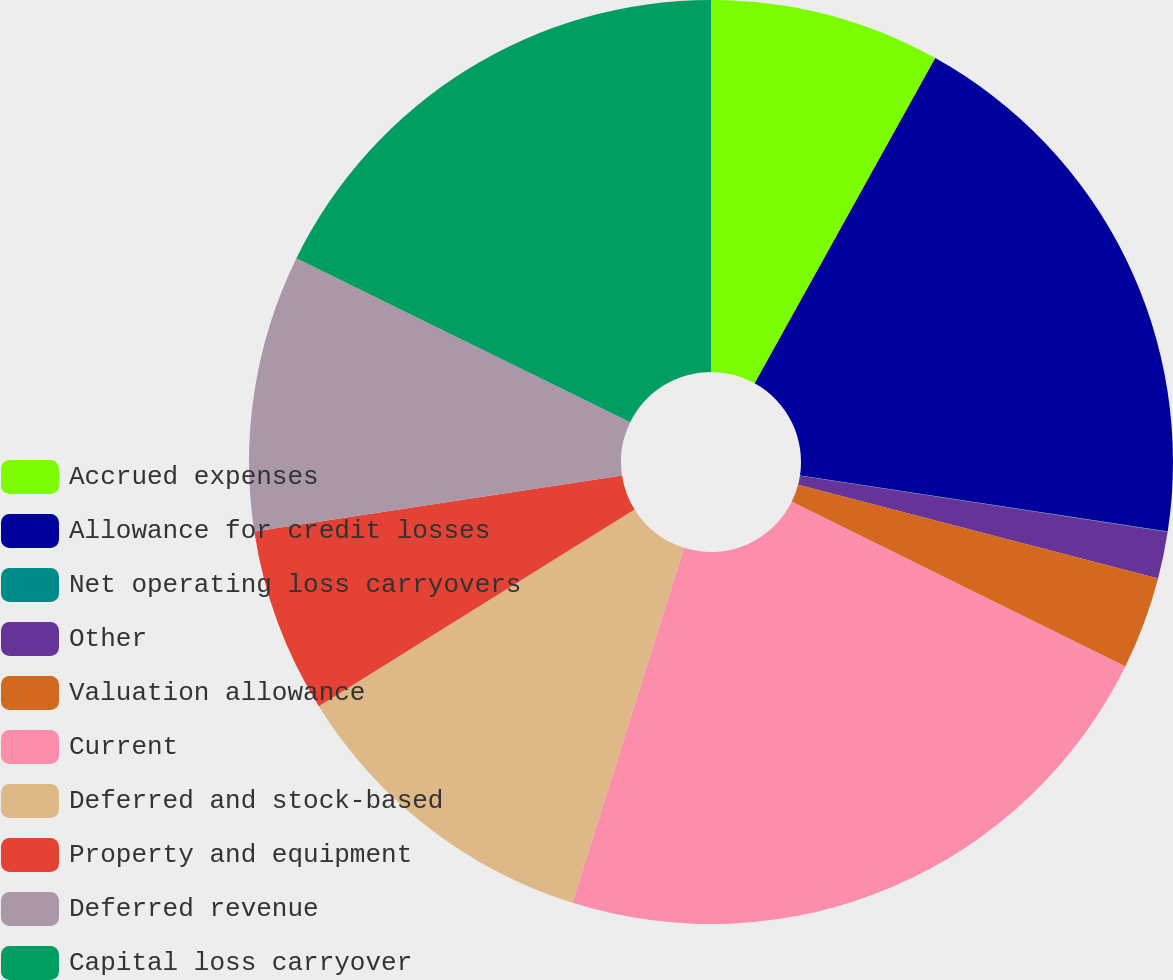Convert chart. <chart><loc_0><loc_0><loc_500><loc_500><pie_chart><fcel>Accrued expenses<fcel>Allowance for credit losses<fcel>Net operating loss carryovers<fcel>Other<fcel>Valuation allowance<fcel>Current<fcel>Deferred and stock-based<fcel>Property and equipment<fcel>Deferred revenue<fcel>Capital loss carryover<nl><fcel>8.07%<fcel>19.34%<fcel>0.02%<fcel>1.63%<fcel>3.24%<fcel>22.56%<fcel>11.29%<fcel>6.46%<fcel>9.68%<fcel>17.73%<nl></chart> 